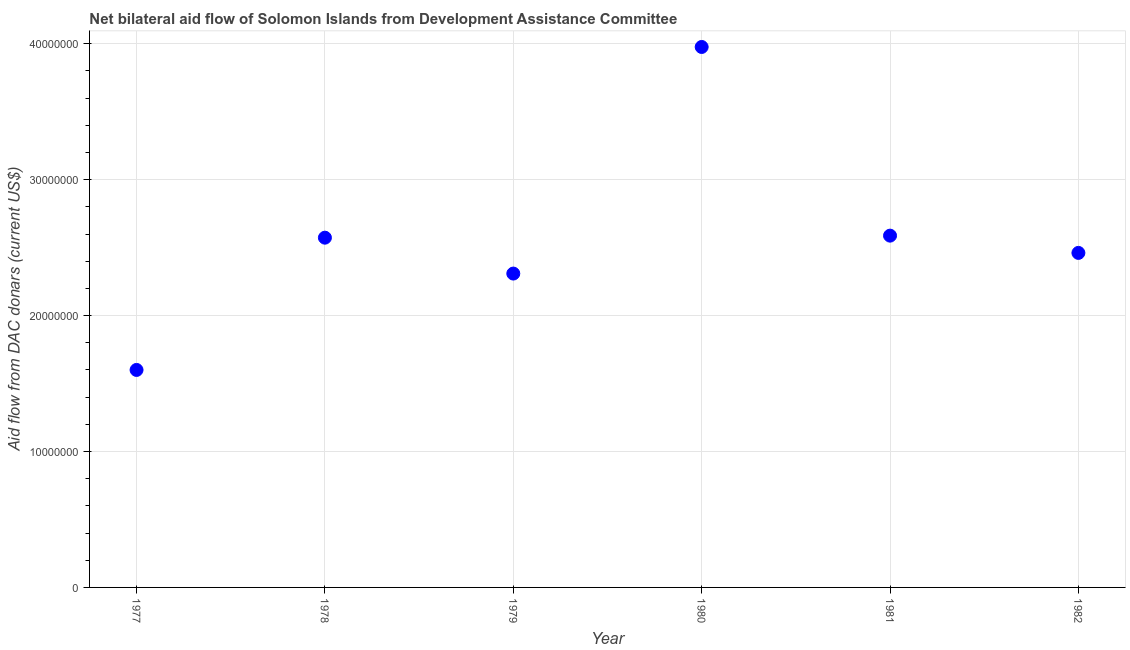What is the net bilateral aid flows from dac donors in 1981?
Your answer should be compact. 2.59e+07. Across all years, what is the maximum net bilateral aid flows from dac donors?
Provide a short and direct response. 3.98e+07. Across all years, what is the minimum net bilateral aid flows from dac donors?
Your answer should be compact. 1.60e+07. In which year was the net bilateral aid flows from dac donors maximum?
Your answer should be very brief. 1980. In which year was the net bilateral aid flows from dac donors minimum?
Your answer should be compact. 1977. What is the sum of the net bilateral aid flows from dac donors?
Provide a short and direct response. 1.55e+08. What is the difference between the net bilateral aid flows from dac donors in 1977 and 1979?
Offer a terse response. -7.09e+06. What is the average net bilateral aid flows from dac donors per year?
Offer a very short reply. 2.58e+07. What is the median net bilateral aid flows from dac donors?
Provide a short and direct response. 2.52e+07. In how many years, is the net bilateral aid flows from dac donors greater than 34000000 US$?
Provide a succinct answer. 1. Do a majority of the years between 1978 and 1980 (inclusive) have net bilateral aid flows from dac donors greater than 38000000 US$?
Provide a succinct answer. No. What is the ratio of the net bilateral aid flows from dac donors in 1977 to that in 1978?
Provide a short and direct response. 0.62. Is the difference between the net bilateral aid flows from dac donors in 1979 and 1980 greater than the difference between any two years?
Ensure brevity in your answer.  No. What is the difference between the highest and the second highest net bilateral aid flows from dac donors?
Provide a short and direct response. 1.39e+07. Is the sum of the net bilateral aid flows from dac donors in 1977 and 1980 greater than the maximum net bilateral aid flows from dac donors across all years?
Your response must be concise. Yes. What is the difference between the highest and the lowest net bilateral aid flows from dac donors?
Ensure brevity in your answer.  2.38e+07. How many dotlines are there?
Your answer should be compact. 1. What is the difference between two consecutive major ticks on the Y-axis?
Give a very brief answer. 1.00e+07. Does the graph contain any zero values?
Your response must be concise. No. What is the title of the graph?
Offer a terse response. Net bilateral aid flow of Solomon Islands from Development Assistance Committee. What is the label or title of the X-axis?
Provide a short and direct response. Year. What is the label or title of the Y-axis?
Offer a very short reply. Aid flow from DAC donars (current US$). What is the Aid flow from DAC donars (current US$) in 1977?
Make the answer very short. 1.60e+07. What is the Aid flow from DAC donars (current US$) in 1978?
Provide a succinct answer. 2.57e+07. What is the Aid flow from DAC donars (current US$) in 1979?
Provide a succinct answer. 2.31e+07. What is the Aid flow from DAC donars (current US$) in 1980?
Ensure brevity in your answer.  3.98e+07. What is the Aid flow from DAC donars (current US$) in 1981?
Provide a succinct answer. 2.59e+07. What is the Aid flow from DAC donars (current US$) in 1982?
Offer a very short reply. 2.46e+07. What is the difference between the Aid flow from DAC donars (current US$) in 1977 and 1978?
Make the answer very short. -9.73e+06. What is the difference between the Aid flow from DAC donars (current US$) in 1977 and 1979?
Provide a succinct answer. -7.09e+06. What is the difference between the Aid flow from DAC donars (current US$) in 1977 and 1980?
Offer a terse response. -2.38e+07. What is the difference between the Aid flow from DAC donars (current US$) in 1977 and 1981?
Provide a short and direct response. -9.88e+06. What is the difference between the Aid flow from DAC donars (current US$) in 1977 and 1982?
Provide a succinct answer. -8.61e+06. What is the difference between the Aid flow from DAC donars (current US$) in 1978 and 1979?
Keep it short and to the point. 2.64e+06. What is the difference between the Aid flow from DAC donars (current US$) in 1978 and 1980?
Offer a terse response. -1.40e+07. What is the difference between the Aid flow from DAC donars (current US$) in 1978 and 1981?
Your answer should be very brief. -1.50e+05. What is the difference between the Aid flow from DAC donars (current US$) in 1978 and 1982?
Provide a short and direct response. 1.12e+06. What is the difference between the Aid flow from DAC donars (current US$) in 1979 and 1980?
Your answer should be very brief. -1.67e+07. What is the difference between the Aid flow from DAC donars (current US$) in 1979 and 1981?
Ensure brevity in your answer.  -2.79e+06. What is the difference between the Aid flow from DAC donars (current US$) in 1979 and 1982?
Your answer should be compact. -1.52e+06. What is the difference between the Aid flow from DAC donars (current US$) in 1980 and 1981?
Offer a terse response. 1.39e+07. What is the difference between the Aid flow from DAC donars (current US$) in 1980 and 1982?
Give a very brief answer. 1.52e+07. What is the difference between the Aid flow from DAC donars (current US$) in 1981 and 1982?
Keep it short and to the point. 1.27e+06. What is the ratio of the Aid flow from DAC donars (current US$) in 1977 to that in 1978?
Provide a short and direct response. 0.62. What is the ratio of the Aid flow from DAC donars (current US$) in 1977 to that in 1979?
Offer a terse response. 0.69. What is the ratio of the Aid flow from DAC donars (current US$) in 1977 to that in 1980?
Make the answer very short. 0.4. What is the ratio of the Aid flow from DAC donars (current US$) in 1977 to that in 1981?
Give a very brief answer. 0.62. What is the ratio of the Aid flow from DAC donars (current US$) in 1977 to that in 1982?
Your answer should be very brief. 0.65. What is the ratio of the Aid flow from DAC donars (current US$) in 1978 to that in 1979?
Your response must be concise. 1.11. What is the ratio of the Aid flow from DAC donars (current US$) in 1978 to that in 1980?
Your answer should be very brief. 0.65. What is the ratio of the Aid flow from DAC donars (current US$) in 1978 to that in 1982?
Provide a short and direct response. 1.05. What is the ratio of the Aid flow from DAC donars (current US$) in 1979 to that in 1980?
Your answer should be compact. 0.58. What is the ratio of the Aid flow from DAC donars (current US$) in 1979 to that in 1981?
Provide a succinct answer. 0.89. What is the ratio of the Aid flow from DAC donars (current US$) in 1979 to that in 1982?
Provide a succinct answer. 0.94. What is the ratio of the Aid flow from DAC donars (current US$) in 1980 to that in 1981?
Keep it short and to the point. 1.54. What is the ratio of the Aid flow from DAC donars (current US$) in 1980 to that in 1982?
Ensure brevity in your answer.  1.62. What is the ratio of the Aid flow from DAC donars (current US$) in 1981 to that in 1982?
Ensure brevity in your answer.  1.05. 